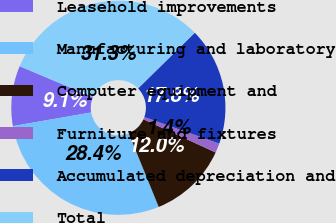<chart> <loc_0><loc_0><loc_500><loc_500><pie_chart><fcel>Leasehold improvements<fcel>Manufacturing and laboratory<fcel>Computer equipment and<fcel>Furniture and fixtures<fcel>Accumulated depreciation and<fcel>Total<nl><fcel>9.08%<fcel>28.41%<fcel>11.99%<fcel>1.42%<fcel>17.79%<fcel>31.31%<nl></chart> 